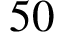<formula> <loc_0><loc_0><loc_500><loc_500>5 0</formula> 